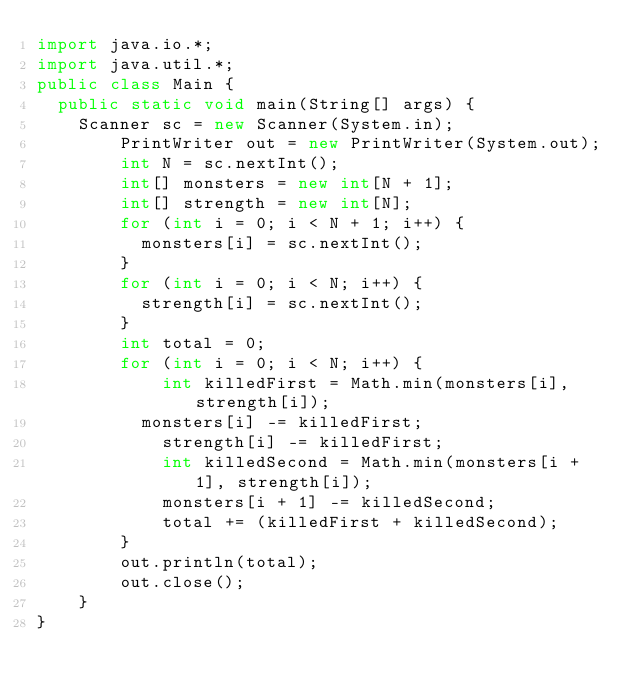<code> <loc_0><loc_0><loc_500><loc_500><_Java_>import java.io.*;
import java.util.*;
public class Main {
	public static void main(String[] args) {
		Scanner sc = new Scanner(System.in);
      	PrintWriter out = new PrintWriter(System.out);
      	int N = sc.nextInt();
      	int[] monsters = new int[N + 1];
      	int[] strength = new int[N];
      	for (int i = 0; i < N + 1; i++) {
        	monsters[i] = sc.nextInt(); 
        }
      	for (int i = 0; i < N; i++) {
        	strength[i] = sc.nextInt(); 
        }
      	int total = 0;
      	for (int i = 0; i < N; i++) {
          	int killedFirst = Math.min(monsters[i], strength[i]);
         	monsters[i] -= killedFirst;
          	strength[i] -= killedFirst;
          	int killedSecond = Math.min(monsters[i + 1], strength[i]);
          	monsters[i + 1] -= killedSecond;
          	total += (killedFirst + killedSecond);
        }
      	out.println(total);
      	out.close();
    }
}</code> 